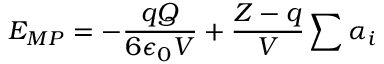<formula> <loc_0><loc_0><loc_500><loc_500>E _ { M P } = - \frac { q Q } { 6 \epsilon _ { 0 } V } + \frac { Z - q } { V } \sum \alpha _ { i }</formula> 